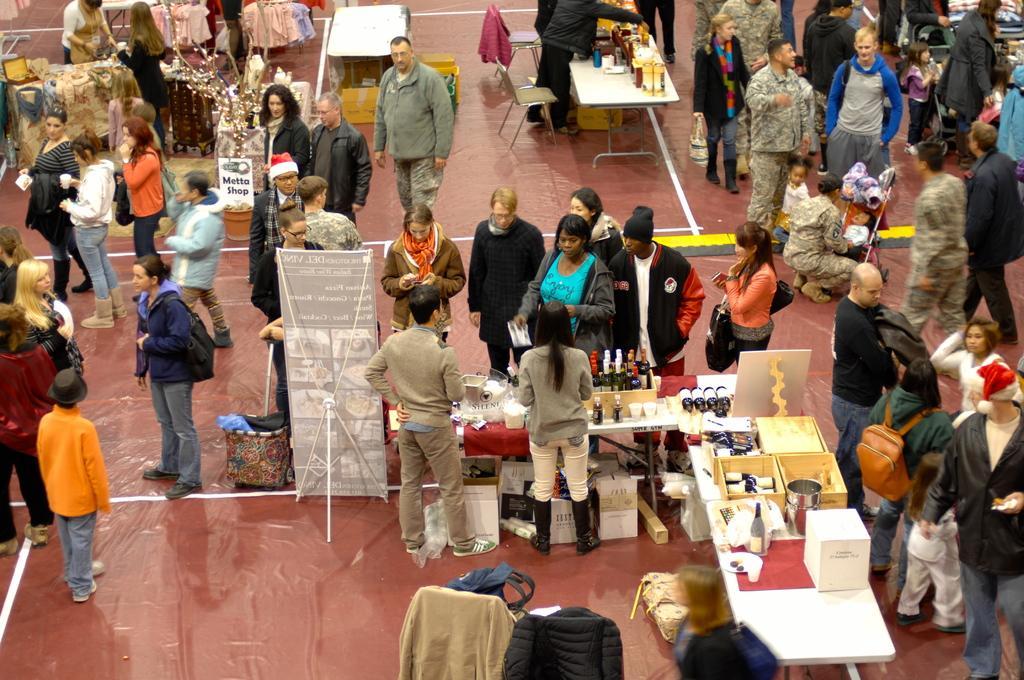How would you summarize this image in a sentence or two? In this image there are a group of people standing, and some of them are walking and some of them are wearing bags and in the foreground there are some stores and tables. On the tables there are some boxes, bottle, plates and some other objects. And at the bottom there are some clothes, in the background also there are some tablecloths and chairs. On the tables there are some bottles and some objects, at the bottom there is floor. 